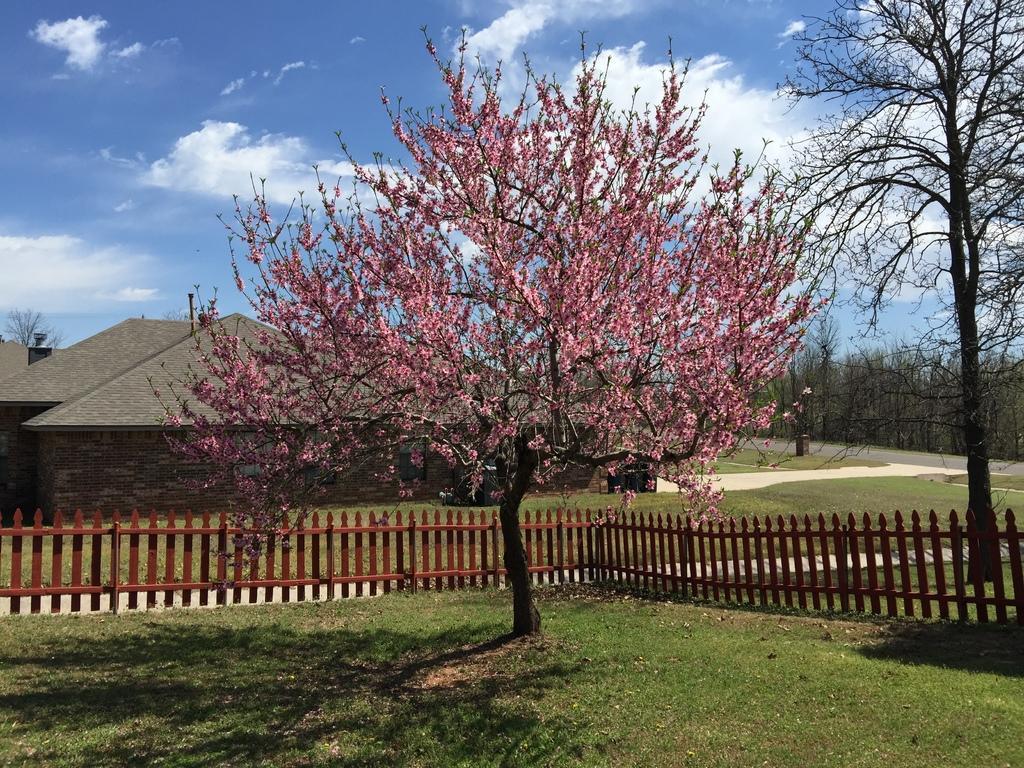In one or two sentences, can you explain what this image depicts? In this image I can see the ground, some grass, a tree to which I can see few flowers which are pink in color and the brown colored railing. In the background I can see few buildings, few trees, the road and the sky. 